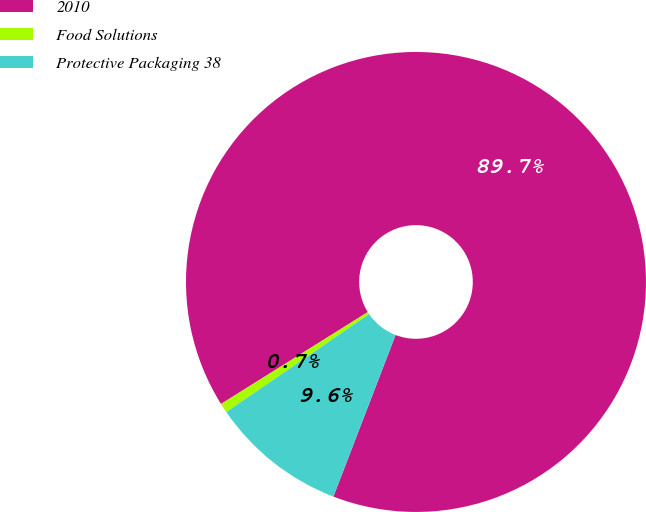Convert chart. <chart><loc_0><loc_0><loc_500><loc_500><pie_chart><fcel>2010<fcel>Food Solutions<fcel>Protective Packaging 38<nl><fcel>89.74%<fcel>0.67%<fcel>9.58%<nl></chart> 